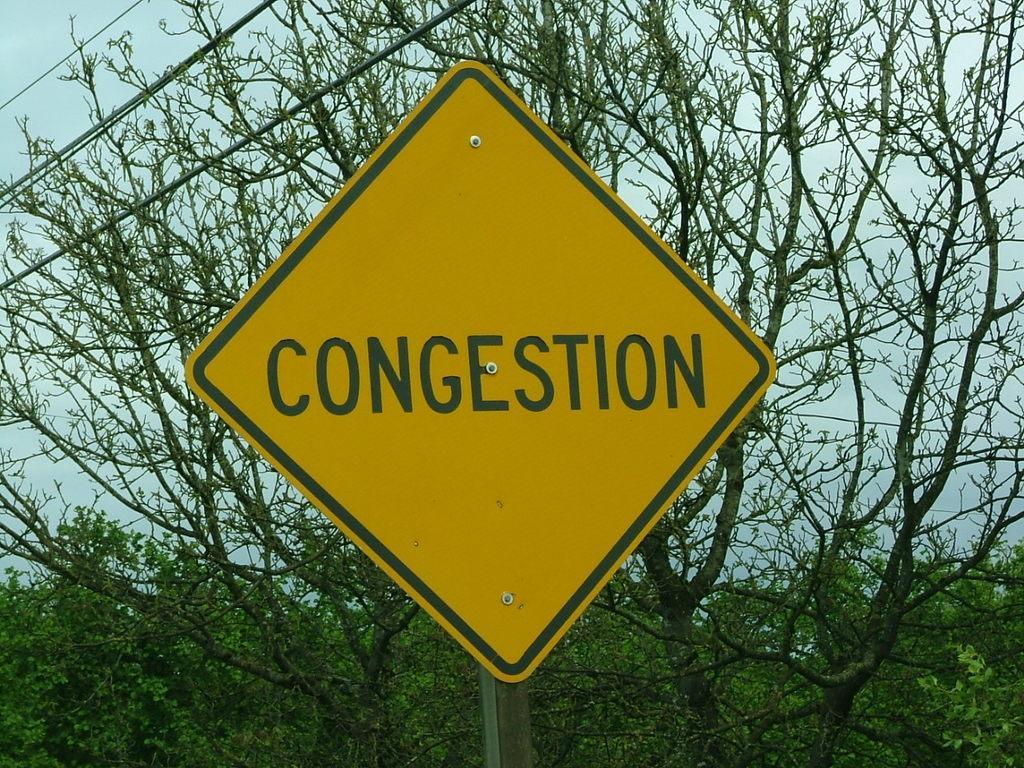Describe this image in one or two sentences. In the picture I can see a yellow color board on which we can see some text. In the background, we can see trees, wires and the sky. 